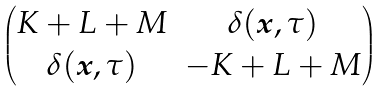Convert formula to latex. <formula><loc_0><loc_0><loc_500><loc_500>\begin{pmatrix} K + L + M & \delta ( { \boldsymbol x } , \tau ) \\ \delta ( { \boldsymbol x } , \tau ) & - K + L + M \end{pmatrix}</formula> 